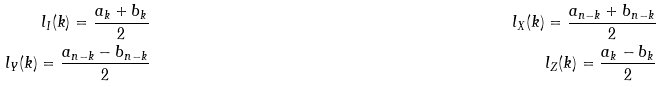<formula> <loc_0><loc_0><loc_500><loc_500>l _ { I } ( k ) = \frac { a _ { k } + b _ { k } } { 2 } & & l _ { X } ( k ) = \frac { a _ { n - k } + b _ { n - k } } { 2 } \\ l _ { Y } ( k ) = \frac { a _ { n - k } - b _ { n - k } } { 2 } & & l _ { Z } ( k ) = \frac { a _ { k } - b _ { k } } { 2 }</formula> 